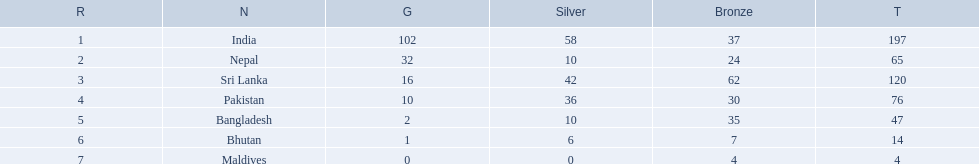Help me parse the entirety of this table. {'header': ['R', 'N', 'G', 'Silver', 'Bronze', 'T'], 'rows': [['1', 'India', '102', '58', '37', '197'], ['2', 'Nepal', '32', '10', '24', '65'], ['3', 'Sri Lanka', '16', '42', '62', '120'], ['4', 'Pakistan', '10', '36', '30', '76'], ['5', 'Bangladesh', '2', '10', '35', '47'], ['6', 'Bhutan', '1', '6', '7', '14'], ['7', 'Maldives', '0', '0', '4', '4']]} What are the nations? India, Nepal, Sri Lanka, Pakistan, Bangladesh, Bhutan, Maldives. Of these, which one has earned the least amount of gold medals? Maldives. 